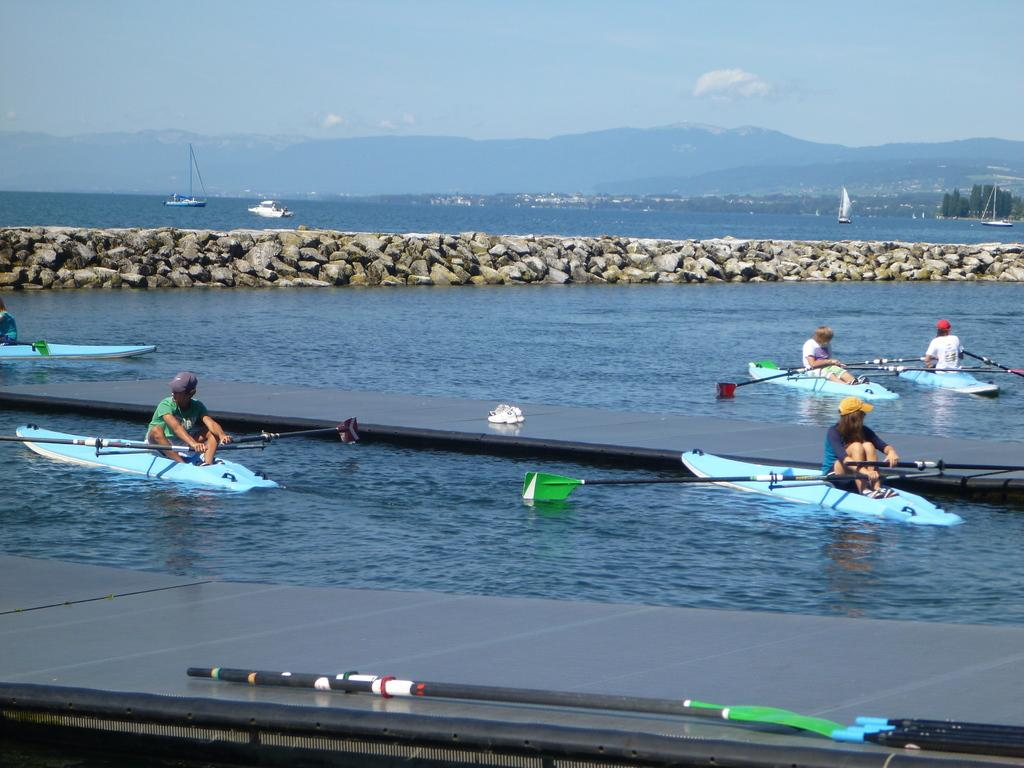What are the boys doing in the image? The boys are sitting in a small boat and riding it. What can be seen behind the boat? There are stones visible behind the boat. What else is present in the background of the image? There are other boats and mountains visible in the background. What type of trick are the boys performing with the boat? There is no indication in the image that the boys are performing any tricks with the boat. 